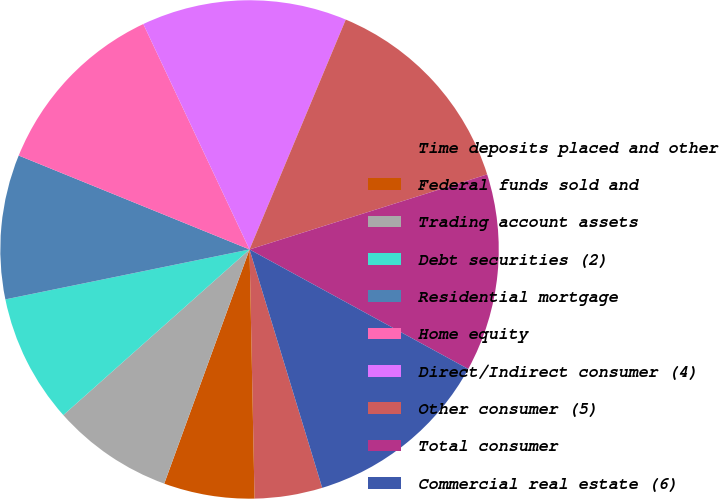<chart> <loc_0><loc_0><loc_500><loc_500><pie_chart><fcel>Time deposits placed and other<fcel>Federal funds sold and<fcel>Trading account assets<fcel>Debt securities (2)<fcel>Residential mortgage<fcel>Home equity<fcel>Direct/Indirect consumer (4)<fcel>Other consumer (5)<fcel>Total consumer<fcel>Commercial real estate (6)<nl><fcel>4.39%<fcel>5.88%<fcel>7.87%<fcel>8.36%<fcel>9.36%<fcel>11.84%<fcel>13.32%<fcel>13.82%<fcel>12.83%<fcel>12.33%<nl></chart> 